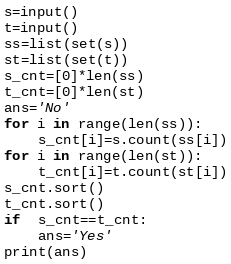Convert code to text. <code><loc_0><loc_0><loc_500><loc_500><_Python_>s=input()
t=input()
ss=list(set(s))
st=list(set(t))
s_cnt=[0]*len(ss)
t_cnt=[0]*len(st)
ans='No'
for i in range(len(ss)):
    s_cnt[i]=s.count(ss[i])
for i in range(len(st)):
    t_cnt[i]=t.count(st[i])
s_cnt.sort()
t_cnt.sort()
if  s_cnt==t_cnt:
    ans='Yes'
print(ans)</code> 